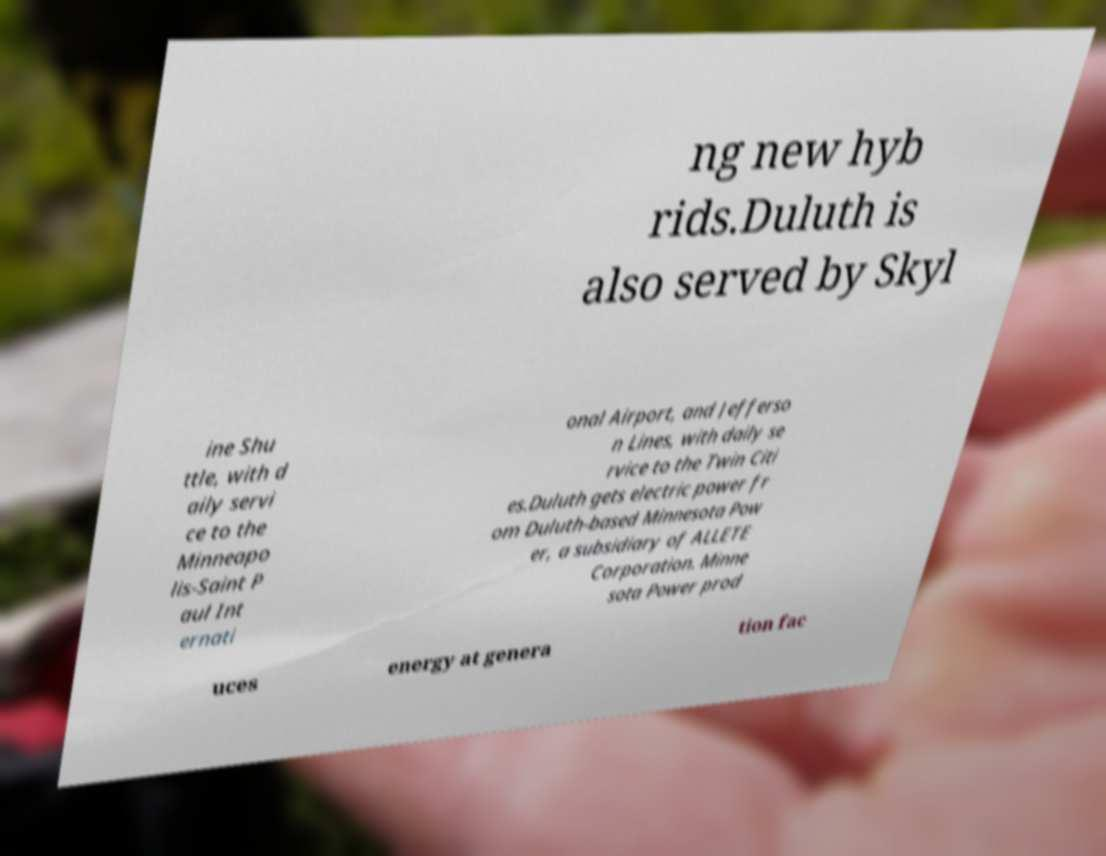Could you extract and type out the text from this image? ng new hyb rids.Duluth is also served by Skyl ine Shu ttle, with d aily servi ce to the Minneapo lis-Saint P aul Int ernati onal Airport, and Jefferso n Lines, with daily se rvice to the Twin Citi es.Duluth gets electric power fr om Duluth-based Minnesota Pow er, a subsidiary of ALLETE Corporation. Minne sota Power prod uces energy at genera tion fac 